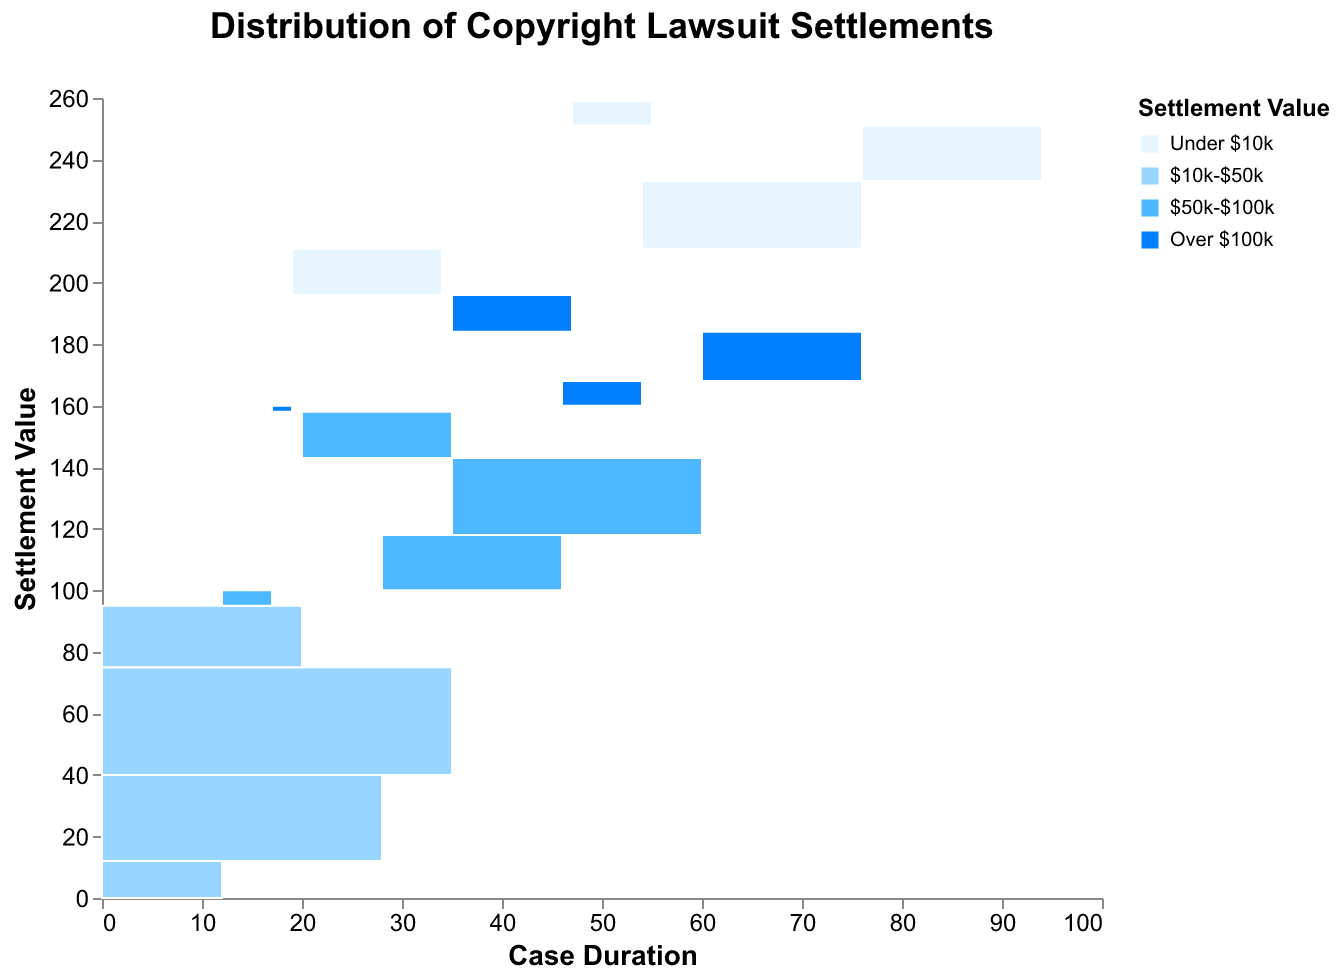How many total cases were settled for a value between $10k-$50k for durations of less than 6 months? Sum the count for all cases with a settlement value of $10k-$50k and duration less than 6 months.
Answer: 12 Which case duration has the highest number of settlements for a value of over $100k? Identify the highest count among the case durations for the category "Over $100k". The highest value is for "1-2 years" with a count of 16.
Answer: 1-2 years What is the total number of cases that lasted over 2 years regardless of settlement value? Add the counts for all settlement values where the case duration is "Over 2 years". The sum is 8 + 20 + 15 + 12.
Answer: 55 Which settlement value has the largest number of cases lasting 6-12 months? Compare the numbers for each settlement value within the "6-12 months" duration. The highest count is in the "$10k-$50k" category with 28 cases.
Answer: $10k-$50k For cases lasting less than 6 months, which settlement value category has the fewest number of cases? Compare the counts for each settlement value within the "Less than 6 months" duration. The lowest count is in the "Over $100k" category with 2 cases.
Answer: Over $100k How many more cases settled for under $10k lasted 6-12 months compared to those that lasted over 2 years? Subtract the number of cases for the "Under $10k" settlement value and duration "Over 2 years" from those lasting "6-12 months". The computation is 22 - 8.
Answer: 14 What is the total number of cases with a settlement value over $50k? Add the counts for "$50k-$100k" and "Over $100k" across all case durations. The sum is 5 + 18 + 25 + 15 + 2 + 8 + 16 + 12.
Answer: 101 Among cases lasting 1-2 years, which settlement value category has the highest number of results? Identify the highest count among the settlement value categories for cases lasting 1-2 years. The highest value is for "$10k-$50k" with a count of 35.
Answer: $10k-$50k What is the fraction of total cases lasting 1-2 years that settled for under $10k? Divide the number of cases with settlement value "Under $10k" and duration "1-2 years" by the total number of cases with duration "1-2 years". The calculation is 18 / (18 + 35 + 25 + 16).
Answer: Approximately 0.18 